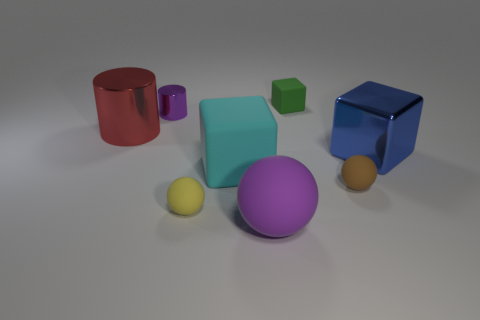Are there any rubber spheres behind the shiny cylinder that is left of the purple shiny cylinder?
Keep it short and to the point. No. Is the number of tiny cylinders less than the number of cyan rubber spheres?
Offer a terse response. No. How many large metallic things are the same shape as the tiny purple object?
Your answer should be compact. 1. How many green objects are tiny matte cubes or matte blocks?
Offer a terse response. 1. What size is the rubber cube in front of the metallic object that is behind the red cylinder?
Your response must be concise. Large. There is a cyan object that is the same shape as the green matte object; what material is it?
Give a very brief answer. Rubber. How many cyan rubber blocks are the same size as the red shiny cylinder?
Your answer should be very brief. 1. Do the green cube and the metallic cube have the same size?
Give a very brief answer. No. There is a matte thing that is behind the small brown ball and in front of the big blue block; what size is it?
Your answer should be very brief. Large. Are there more big matte cubes in front of the large blue block than small green objects to the left of the purple cylinder?
Your answer should be compact. Yes. 